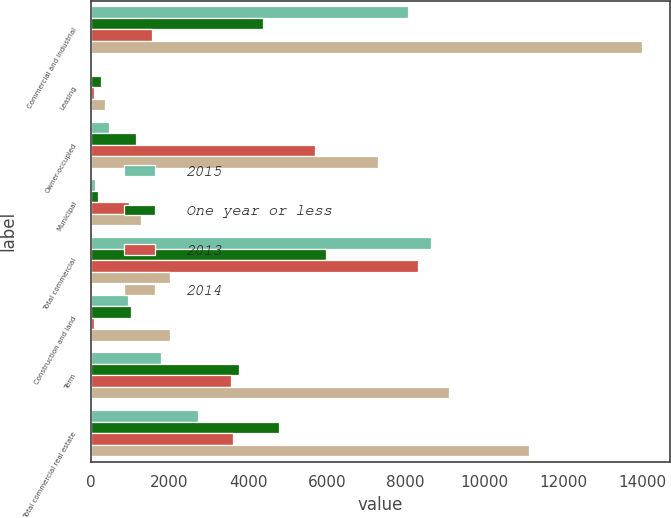Convert chart to OTSL. <chart><loc_0><loc_0><loc_500><loc_500><stacked_bar_chart><ecel><fcel>Commercial and industrial<fcel>Leasing<fcel>Owner-occupied<fcel>Municipal<fcel>Total commercial<fcel>Construction and land<fcel>Term<fcel>Total commercial real estate<nl><fcel>2015<fcel>8064<fcel>26<fcel>463<fcel>100<fcel>8653<fcel>931<fcel>1779<fcel>2710<nl><fcel>One year or less<fcel>4375<fcel>262<fcel>1138<fcel>191<fcel>5966<fcel>1016<fcel>3775<fcel>4791<nl><fcel>2013<fcel>1564<fcel>76<fcel>5687<fcel>980<fcel>8307<fcel>74<fcel>3549<fcel>3623<nl><fcel>2014<fcel>14003<fcel>364<fcel>7288<fcel>1271<fcel>2021<fcel>2021<fcel>9103<fcel>11124<nl></chart> 